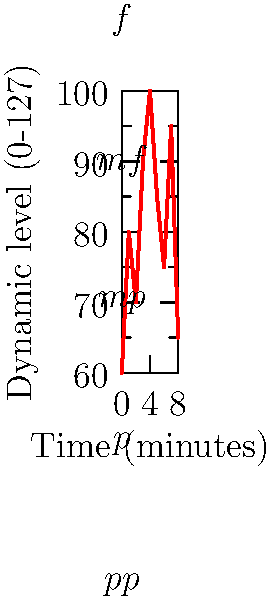Analyze the graph representing the dynamic markings of Rachmaninoff's Piano Concerto No. 2 in C minor, Op. 18. At which time point does the concerto reach its highest dynamic level, and what traditional dynamic marking would this correspond to in classical notation? To answer this question, we need to follow these steps:

1. Examine the y-axis to understand the dynamic level scale (0-127).
2. Scan the graph to find the highest point on the curve.
3. Identify the corresponding time on the x-axis for this highest point.
4. Relate the highest dynamic level to traditional dynamic markings.

Analyzing the graph:
1. The y-axis represents dynamic levels from 0 to 127, which corresponds to MIDI velocity values.
2. The highest point on the curve reaches a dynamic level of 100.
3. This peak occurs at the 4-minute mark on the x-axis.
4. In classical notation:
   - $pp$ (pianissimo) is around 30
   - $p$ (piano) is around 50
   - $mp$ (mezzo-piano) is around 70
   - $mf$ (mezzo-forte) is around 90
   - $f$ (forte) is around 110

The peak at 100 falls between $mf$ and $f$, but is closer to $f$. In Rachmaninoff's works, this dynamic level would typically be notated as $f$ (forte).
Answer: 4 minutes, $f$ (forte) 